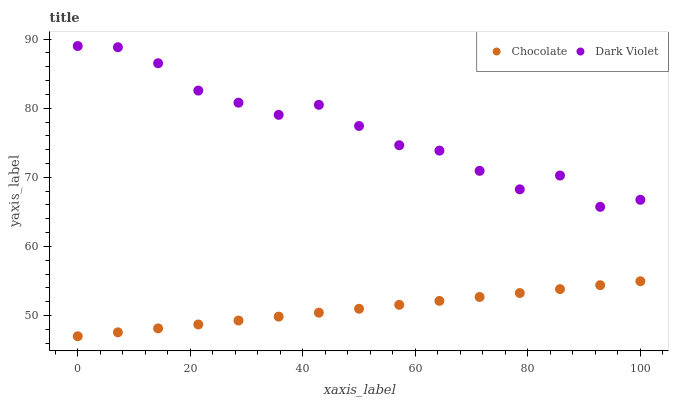Does Chocolate have the minimum area under the curve?
Answer yes or no. Yes. Does Dark Violet have the maximum area under the curve?
Answer yes or no. Yes. Does Chocolate have the maximum area under the curve?
Answer yes or no. No. Is Chocolate the smoothest?
Answer yes or no. Yes. Is Dark Violet the roughest?
Answer yes or no. Yes. Is Chocolate the roughest?
Answer yes or no. No. Does Chocolate have the lowest value?
Answer yes or no. Yes. Does Dark Violet have the highest value?
Answer yes or no. Yes. Does Chocolate have the highest value?
Answer yes or no. No. Is Chocolate less than Dark Violet?
Answer yes or no. Yes. Is Dark Violet greater than Chocolate?
Answer yes or no. Yes. Does Chocolate intersect Dark Violet?
Answer yes or no. No. 